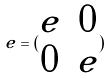Convert formula to latex. <formula><loc_0><loc_0><loc_500><loc_500>e = ( \begin{matrix} e & 0 \\ 0 & e \end{matrix} )</formula> 